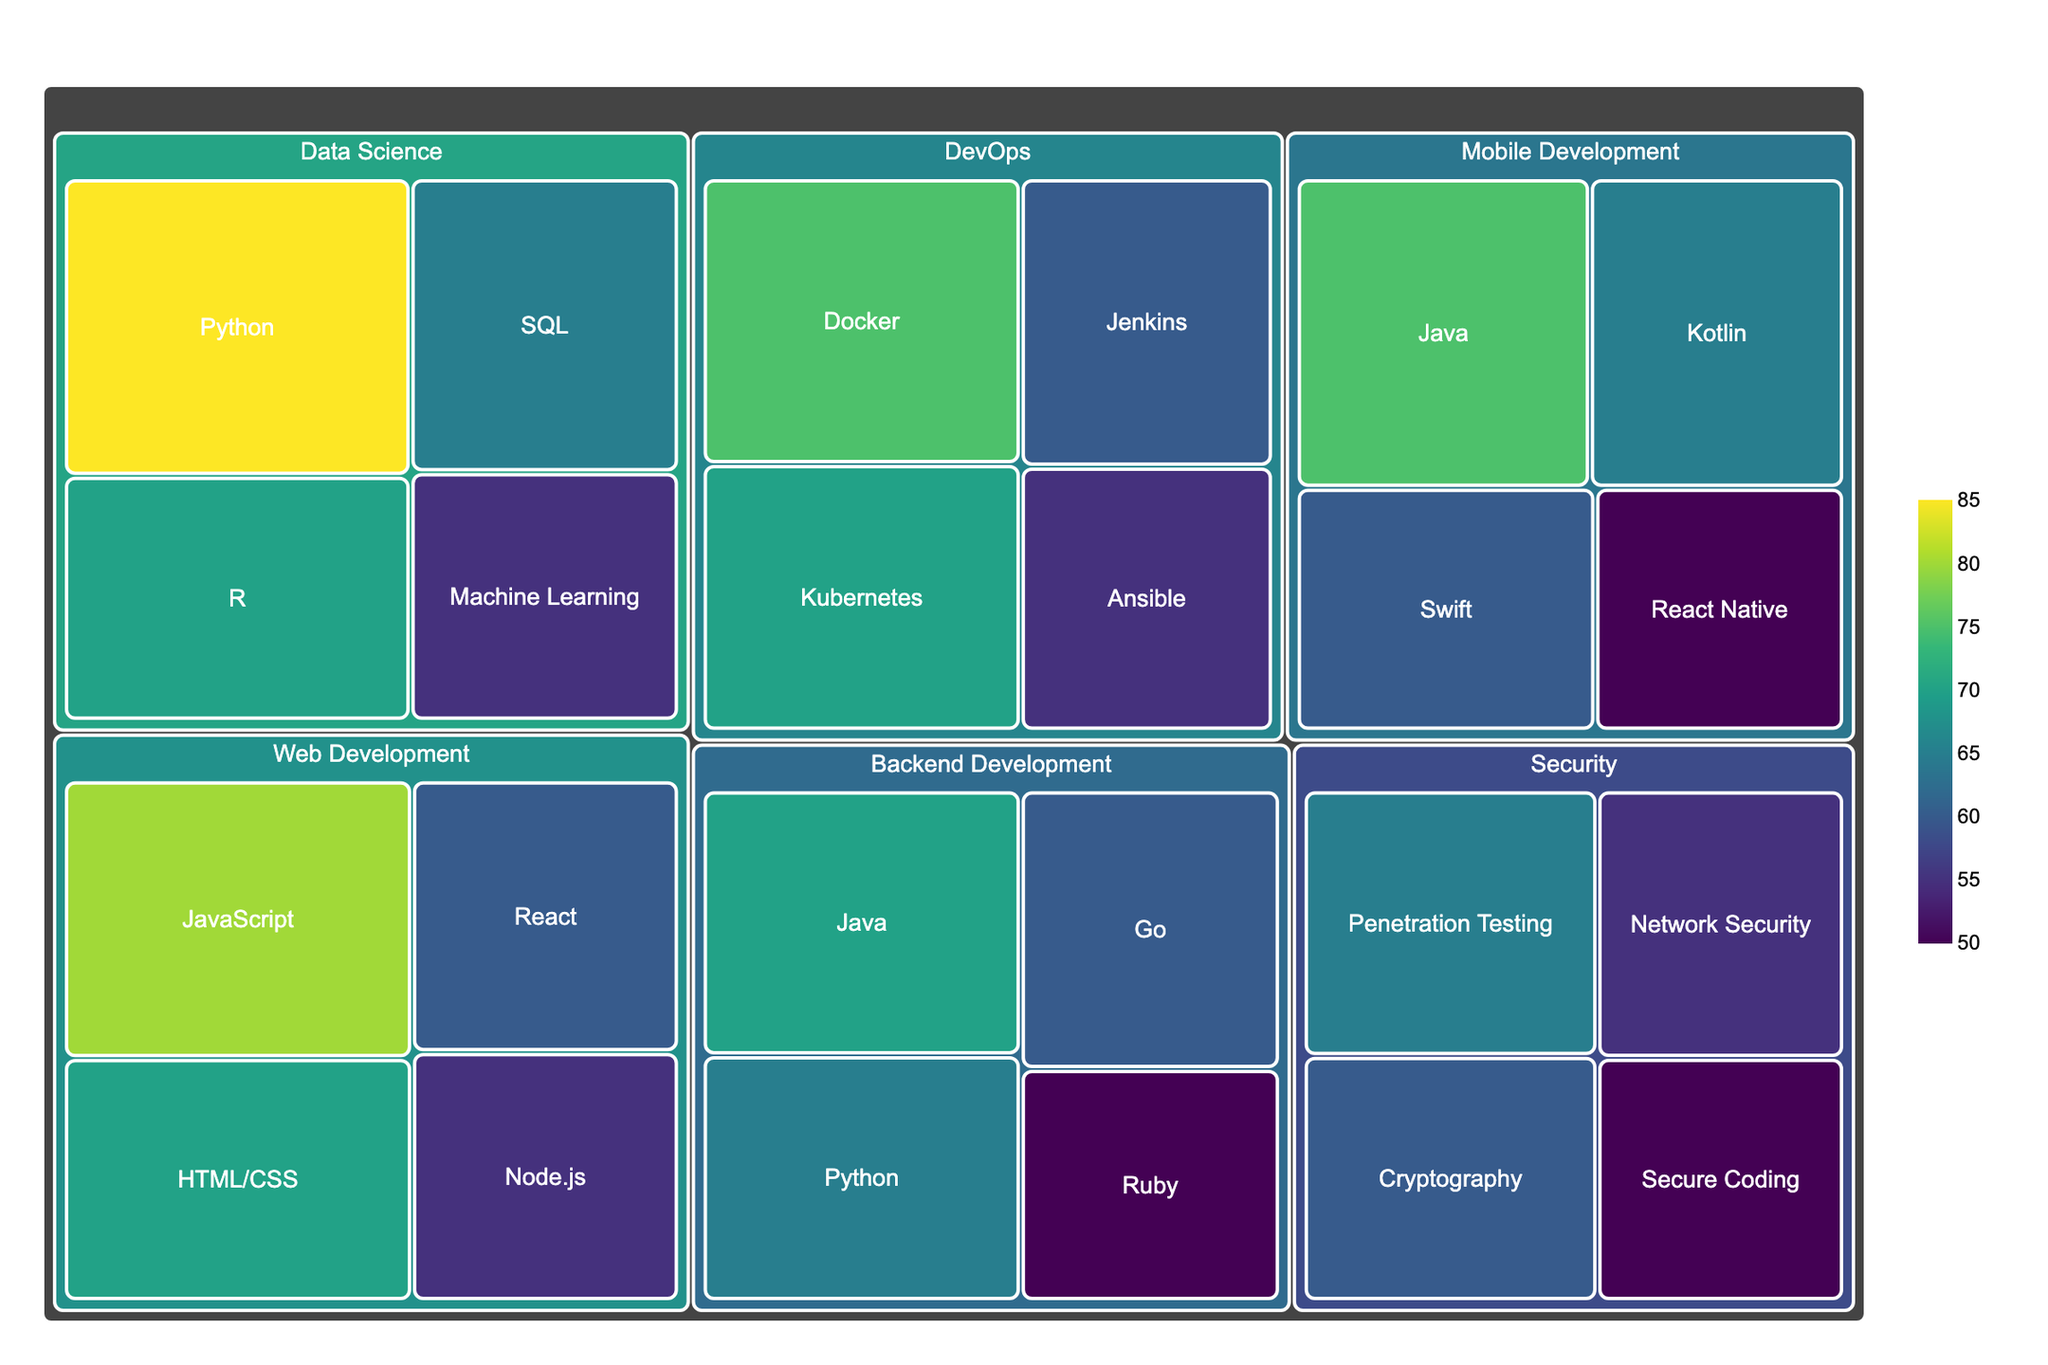What is the title of the treemap? The title of a plot is typically displayed at the top and describes the main subject of the figure. In this case, the title provides an overview of what the treemap represents, focusing on most in-demand skills for entry-level open-source contributors.
Answer: Most In-Demand Skills for Entry-Level Open-Source Contributors Which domain has the highest demanded skill, and what is that skill? To find the highest demanded skill, look at the largest or most saturated colored block in the treemap. This block should have the highest demand value, which is 85, under the Data Science domain for the skill Python.
Answer: Data Science, Python How many skills are listed under Web Development? Count the number of blocks within the Web Development section of the treemap. Each block represents a skill. For Web Development, there are four skills: JavaScript, HTML/CSS, React, and Node.js.
Answer: Four Compare the demand for Java in Mobile Development and Backend Development. Which domain ranks higher for Java? Identify the two blocks representing Java under Mobile Development and Backend Development. Locate their demand values. Java in Mobile Development has a demand of 75, and Java in Backend Development has a demand of 70. Mobile Development ranks higher.
Answer: Mobile Development What is the average demand for skills in the DevOps domain? Add the demand values for all skills in the DevOps domain: Docker (75), Kubernetes (70), Jenkins (60), and Ansible (55). Sum these values to obtain: 75 + 70 + 60 + 55 = 260. Divide by the number of skills, which is 4. The average demand is 260/4 = 65.
Answer: 65 Which skill in the Security domain has the lowest demand, and what is its value? Identify the smallest or least saturated colored block under the Security domain. The block with the lowest demand is Secure Coding, with a value of 50.
Answer: Secure Coding, 50 Is the demand for React higher in Web Development or Mobile Development? Locate the blocks for React in both the Web Development and Mobile Development domains and compare their demand values. React in Web Development has a demand of 60, while React Native in Mobile Development has a demand of 50. React is higher in Web Development.
Answer: Web Development What is the combined demand for SQL and Machine Learning in Data Science? Sum the demand values for SQL and Machine Learning in the Data Science domain. SQL has a demand of 65, and Machine Learning has a demand of 55. The combined demand is 65 + 55 = 120.
Answer: 120 Which domain besides Data Science has a skill with demand greater than or equal to 75? Examine each domain for skills that meet or exceed the demand value of 75. In addition to Data Science, the Mobile Development domain has Java with a demand of 75 and the DevOps domain has Docker with a demand of 75.
Answer: Mobile Development, DevOps 